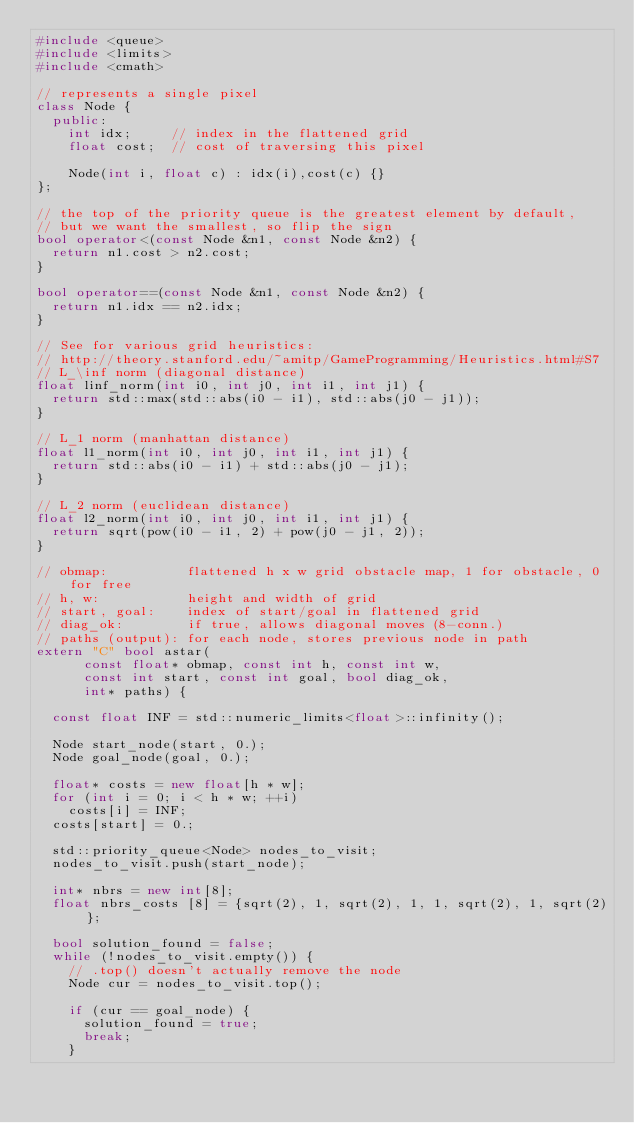Convert code to text. <code><loc_0><loc_0><loc_500><loc_500><_C++_>#include <queue>
#include <limits>
#include <cmath>

// represents a single pixel
class Node {
  public:
    int idx;     // index in the flattened grid
    float cost;  // cost of traversing this pixel

    Node(int i, float c) : idx(i),cost(c) {}
};

// the top of the priority queue is the greatest element by default,
// but we want the smallest, so flip the sign
bool operator<(const Node &n1, const Node &n2) {
  return n1.cost > n2.cost;
}

bool operator==(const Node &n1, const Node &n2) {
  return n1.idx == n2.idx;
}

// See for various grid heuristics:
// http://theory.stanford.edu/~amitp/GameProgramming/Heuristics.html#S7
// L_\inf norm (diagonal distance)
float linf_norm(int i0, int j0, int i1, int j1) {
  return std::max(std::abs(i0 - i1), std::abs(j0 - j1));
}

// L_1 norm (manhattan distance)
float l1_norm(int i0, int j0, int i1, int j1) {
  return std::abs(i0 - i1) + std::abs(j0 - j1);
}

// L_2 norm (euclidean distance)
float l2_norm(int i0, int j0, int i1, int j1) {
  return sqrt(pow(i0 - i1, 2) + pow(j0 - j1, 2));
}

// obmap:          flattened h x w grid obstacle map, 1 for obstacle, 0 for free
// h, w:           height and width of grid
// start, goal:    index of start/goal in flattened grid
// diag_ok:        if true, allows diagonal moves (8-conn.)
// paths (output): for each node, stores previous node in path
extern "C" bool astar(
      const float* obmap, const int h, const int w,
      const int start, const int goal, bool diag_ok,
      int* paths) {

  const float INF = std::numeric_limits<float>::infinity();

  Node start_node(start, 0.);
  Node goal_node(goal, 0.);

  float* costs = new float[h * w];
  for (int i = 0; i < h * w; ++i)
    costs[i] = INF;
  costs[start] = 0.;

  std::priority_queue<Node> nodes_to_visit;
  nodes_to_visit.push(start_node);

  int* nbrs = new int[8];
  float nbrs_costs [8] = {sqrt(2), 1, sqrt(2), 1, 1, sqrt(2), 1, sqrt(2)};

  bool solution_found = false;
  while (!nodes_to_visit.empty()) {
    // .top() doesn't actually remove the node
    Node cur = nodes_to_visit.top();

    if (cur == goal_node) {
      solution_found = true;
      break;
    }
</code> 